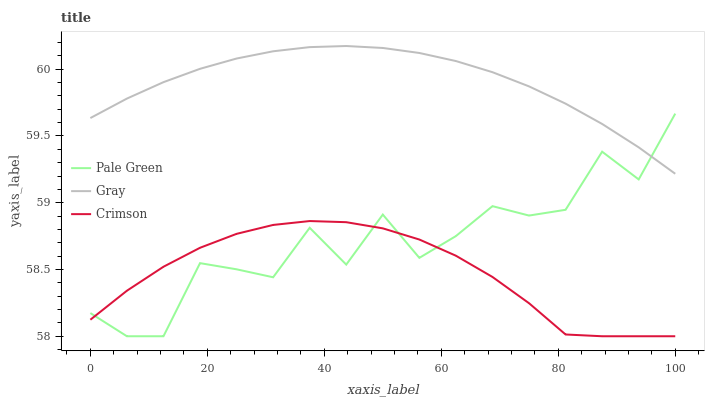Does Crimson have the minimum area under the curve?
Answer yes or no. Yes. Does Gray have the maximum area under the curve?
Answer yes or no. Yes. Does Pale Green have the minimum area under the curve?
Answer yes or no. No. Does Pale Green have the maximum area under the curve?
Answer yes or no. No. Is Gray the smoothest?
Answer yes or no. Yes. Is Pale Green the roughest?
Answer yes or no. Yes. Is Pale Green the smoothest?
Answer yes or no. No. Is Gray the roughest?
Answer yes or no. No. Does Crimson have the lowest value?
Answer yes or no. Yes. Does Gray have the lowest value?
Answer yes or no. No. Does Gray have the highest value?
Answer yes or no. Yes. Does Pale Green have the highest value?
Answer yes or no. No. Is Crimson less than Gray?
Answer yes or no. Yes. Is Gray greater than Crimson?
Answer yes or no. Yes. Does Pale Green intersect Gray?
Answer yes or no. Yes. Is Pale Green less than Gray?
Answer yes or no. No. Is Pale Green greater than Gray?
Answer yes or no. No. Does Crimson intersect Gray?
Answer yes or no. No. 